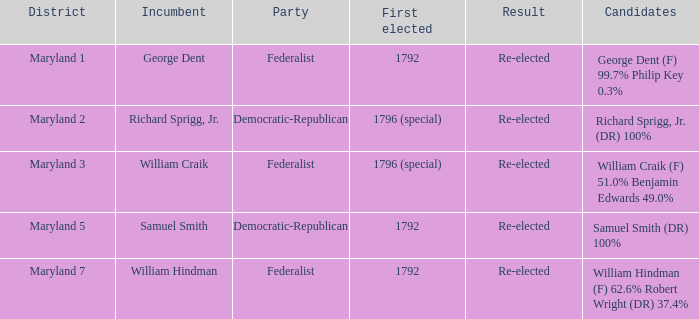 What is the result for the district Maryland 7? Re-elected. I'm looking to parse the entire table for insights. Could you assist me with that? {'header': ['District', 'Incumbent', 'Party', 'First elected', 'Result', 'Candidates'], 'rows': [['Maryland 1', 'George Dent', 'Federalist', '1792', 'Re-elected', 'George Dent (F) 99.7% Philip Key 0.3%'], ['Maryland 2', 'Richard Sprigg, Jr.', 'Democratic-Republican', '1796 (special)', 'Re-elected', 'Richard Sprigg, Jr. (DR) 100%'], ['Maryland 3', 'William Craik', 'Federalist', '1796 (special)', 'Re-elected', 'William Craik (F) 51.0% Benjamin Edwards 49.0%'], ['Maryland 5', 'Samuel Smith', 'Democratic-Republican', '1792', 'Re-elected', 'Samuel Smith (DR) 100%'], ['Maryland 7', 'William Hindman', 'Federalist', '1792', 'Re-elected', 'William Hindman (F) 62.6% Robert Wright (DR) 37.4%']]} 